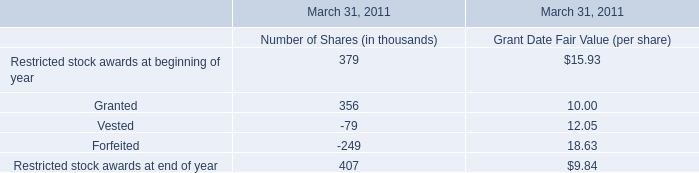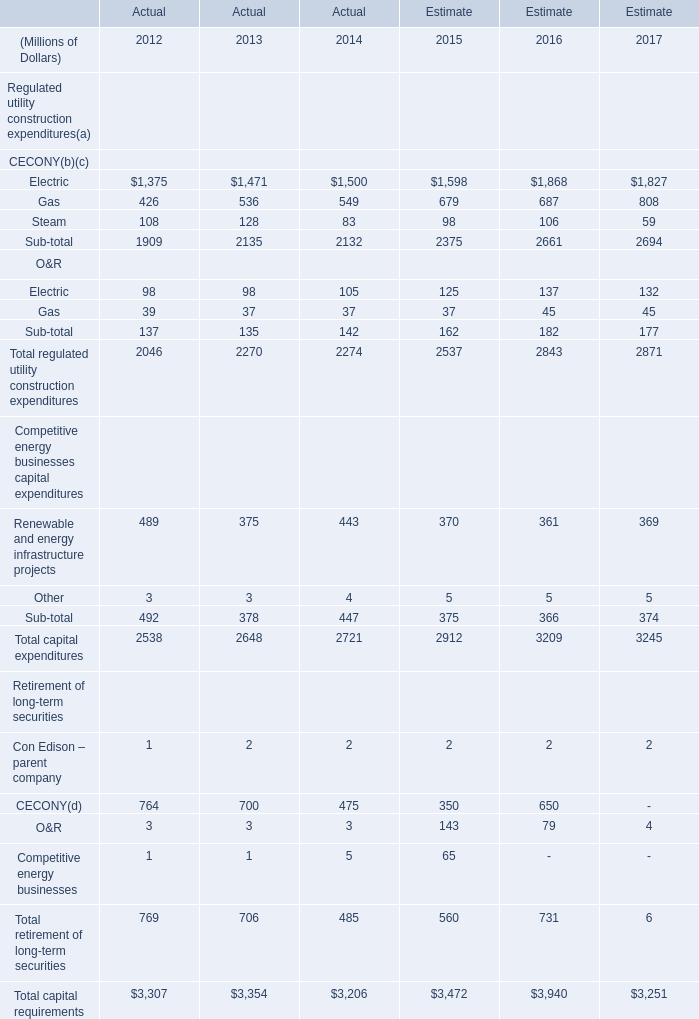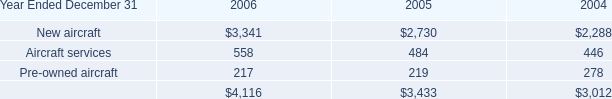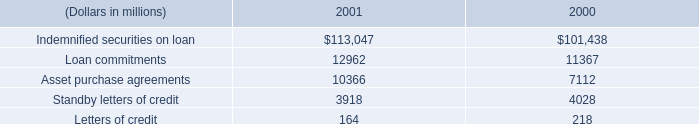what percent did indemnified securities on loan increase between 2000 and 2001? 
Computations: ((113047 - 101438) / 101438)
Answer: 0.11444. 